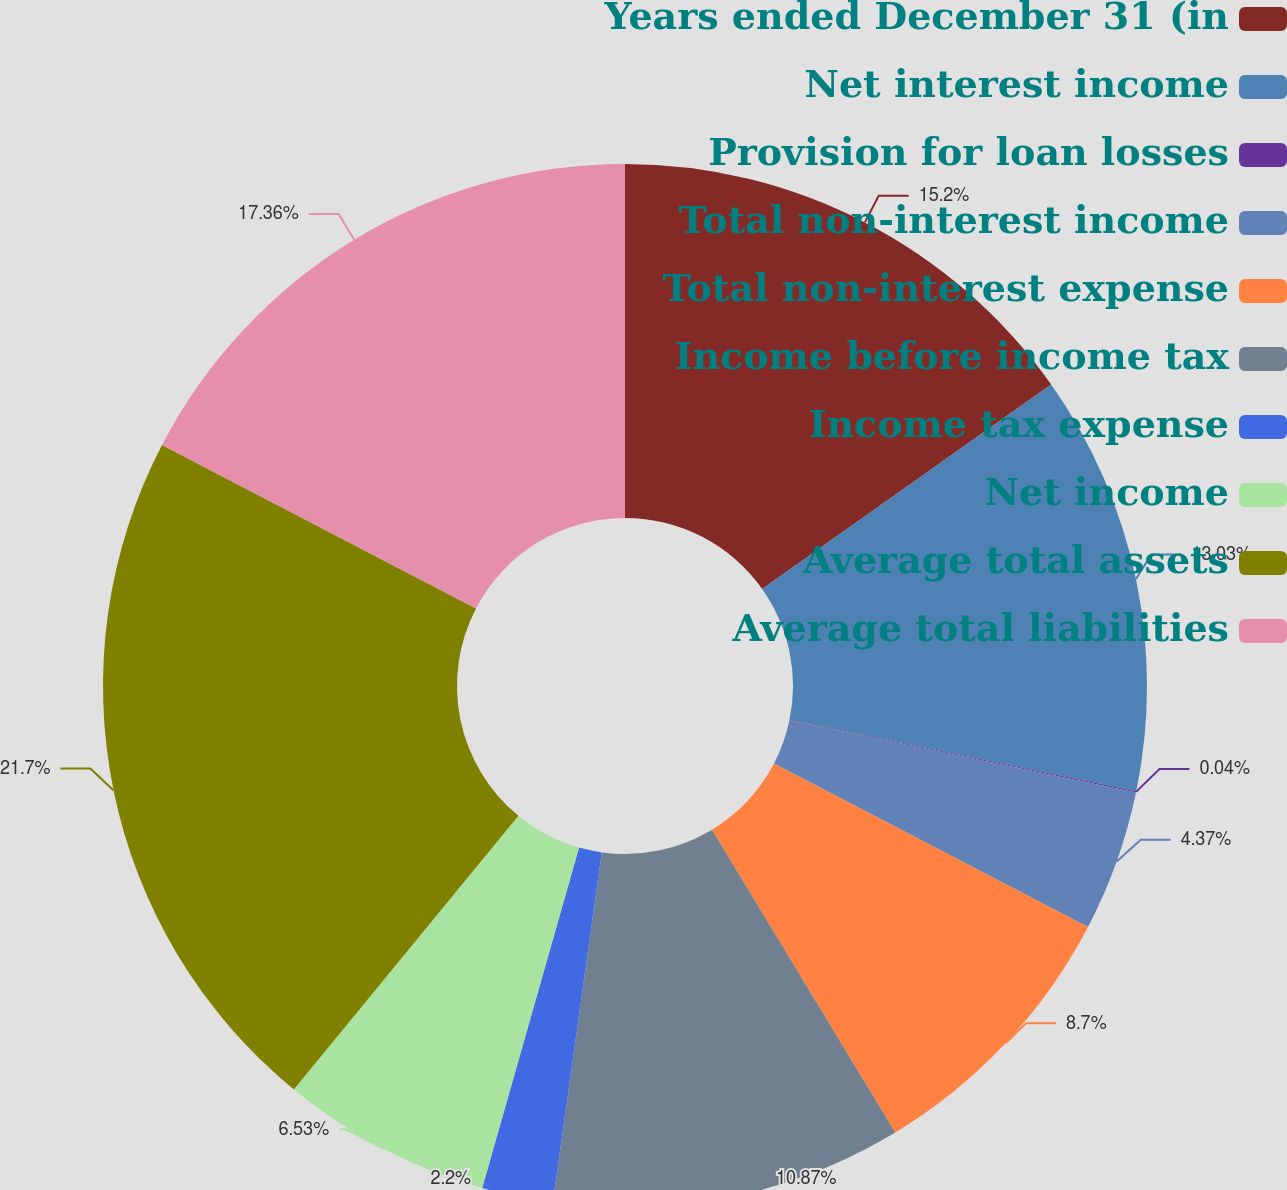Convert chart. <chart><loc_0><loc_0><loc_500><loc_500><pie_chart><fcel>Years ended December 31 (in<fcel>Net interest income<fcel>Provision for loan losses<fcel>Total non-interest income<fcel>Total non-interest expense<fcel>Income before income tax<fcel>Income tax expense<fcel>Net income<fcel>Average total assets<fcel>Average total liabilities<nl><fcel>15.2%<fcel>13.03%<fcel>0.04%<fcel>4.37%<fcel>8.7%<fcel>10.87%<fcel>2.2%<fcel>6.53%<fcel>21.7%<fcel>17.36%<nl></chart> 